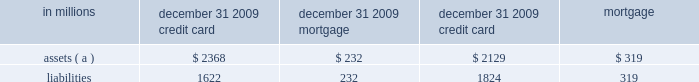Note 10 loan sales and securitizations loan sales we sell residential and commercial mortgage loans in loan securitization transactions sponsored by government national mortgage association ( gnma ) , fnma , and fhlmc and in certain instances to other third-party investors .
Gnma , fnma , and the fhlmc securitize our transferred loans into mortgage-backed securities for sale into the secondary market .
Generally , we do not retain any interest in the transferred loans other than mortgage servicing rights .
Refer to note 9 goodwill and other intangible assets for further discussion on our residential and commercial mortgage servicing rights assets .
During 2009 , residential and commercial mortgage loans sold totaled $ 19.8 billion and $ 5.7 billion , respectively .
During 2008 , commercial mortgage loans sold totaled $ 3.1 billion .
There were no residential mortgage loans sales in 2008 as these activities were obtained through our acquisition of national city .
Our continuing involvement in these loan sales consists primarily of servicing and limited repurchase obligations for loan and servicer breaches in representations and warranties .
Generally , we hold a cleanup call repurchase option for loans sold with servicing retained to the other third-party investors .
In certain circumstances as servicer , we advance principal and interest payments to the gses and other third-party investors and also may make collateral protection advances .
Our risk of loss in these servicing advances has historically been minimal .
We maintain a liability for estimated losses on loans expected to be repurchased as a result of breaches in loan and servicer representations and warranties .
We have also entered into recourse arrangements associated with commercial mortgage loans sold to fnma and fhlmc .
Refer to note 25 commitments and guarantees for further discussion on our repurchase liability and recourse arrangements .
Our maximum exposure to loss in our loan sale activities is limited to these repurchase and recourse obligations .
In addition , for certain loans transferred in the gnma and fnma transactions , we hold an option to repurchase individual delinquent loans that meet certain criteria .
Without prior authorization from these gses , this option gives pnc the ability to repurchase the delinquent loan at par .
Under gaap , once we have the unilateral ability to repurchase the delinquent loan , effective control over the loan has been regained and we are required to recognize the loan and a corresponding repurchase liability on the balance sheet regardless of our intent to repurchase the loan .
At december 31 , 2009 and december 31 , 2008 , the balance of our repurchase option asset and liability totaled $ 577 million and $ 476 million , respectively .
Securitizations in securitizations , loans are typically transferred to a qualifying special purpose entity ( qspe ) that is demonstrably distinct from the transferor to transfer the risk from our consolidated balance sheet .
A qspe is a bankruptcy-remote trust allowed to perform only certain passive activities .
In addition , these entities are self-liquidating and in certain instances are structured as real estate mortgage investment conduits ( remics ) for tax purposes .
The qspes are generally financed by issuing certificates for various levels of senior and subordinated tranches .
Qspes are exempt from consolidation provided certain conditions are met .
Our securitization activities were primarily obtained through our acquisition of national city .
Credit card receivables , automobile , and residential mortgage loans were securitized through qspes sponsored by ncb .
These qspes were financed primarily through the issuance and sale of beneficial interests to independent third parties and were not consolidated on our balance sheet at december 31 , 2009 or december 31 , 2008 .
However , see note 1 accounting policies regarding accounting guidance that impacts the accounting for these qspes effective january 1 , 2010 .
Qualitative and quantitative information about the securitization qspes and our retained interests in these transactions follow .
The following summarizes the assets and liabilities of the securitization qspes associated with securitization transactions that were outstanding at december 31 , 2009. .
( a ) represents period-end outstanding principal balances of loans transferred to the securitization qspes .
Credit card loans at december 31 , 2009 , the credit card securitization series 2005-1 , 2006-1 , 2007-1 , and 2008-3 were outstanding .
During the fourth quarter of 2009 , the 2008-1 and 2008-2 credit card securitization series matured .
Our continuing involvement in the securitized credit card receivables consists primarily of servicing and our holding of certain retained interests .
Servicing fees earned approximate current market rates for servicing fees ; therefore , no servicing asset or liability is recognized .
We hold a clean-up call repurchase option to the extent a securitization series extends past its scheduled note principal payoff date .
To the extent this occurs , the clean-up call option is triggered when the principal balance of the asset- backed notes of any series reaches 5% ( 5 % ) of the initial principal balance of the asset-backed notes issued at the securitization .
For how much more was the 2009 residential loan sold than the 2008 and 2009 commercial loans combined , in billions? 
Computations: (19.8 - (5.7 + 3.1))
Answer: 11.0. 